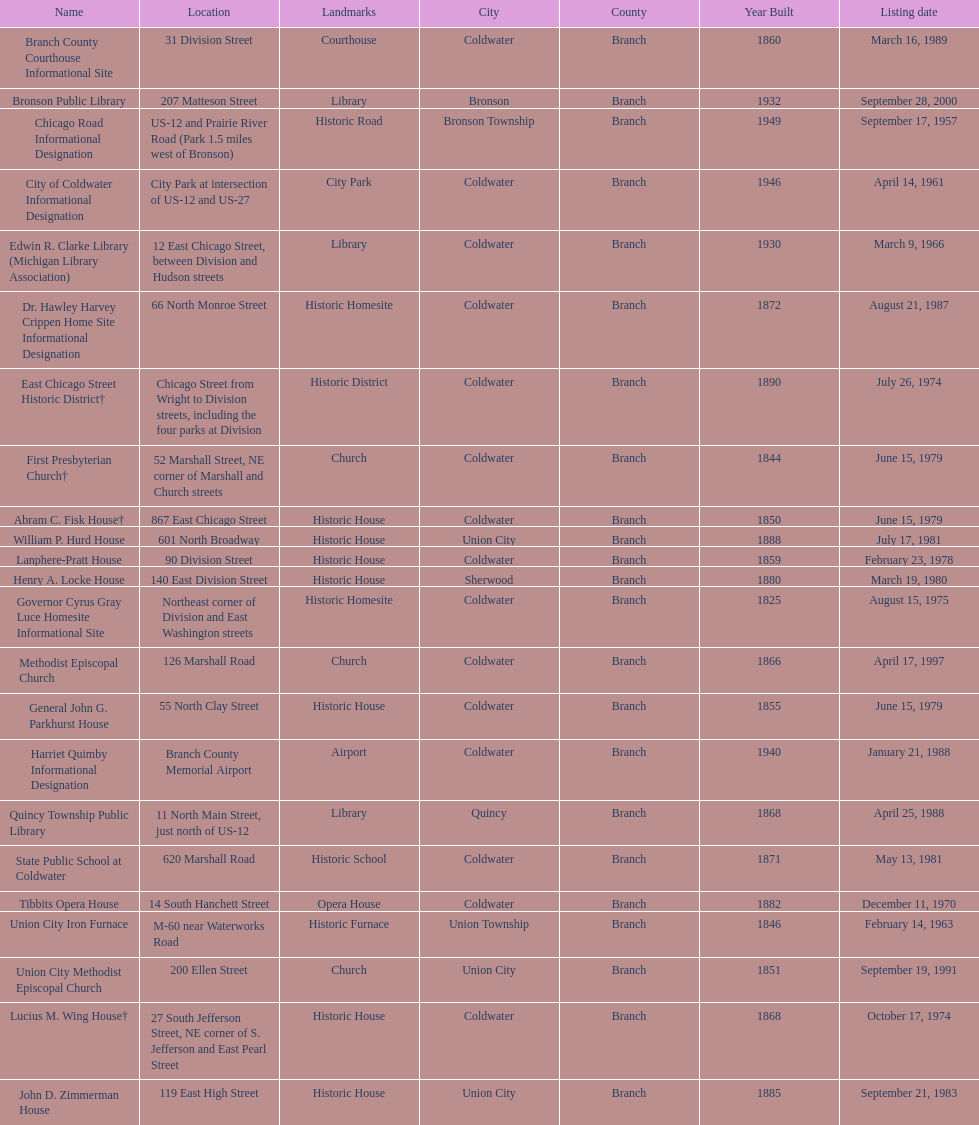What is the total current listing of names on this chart? 23. 